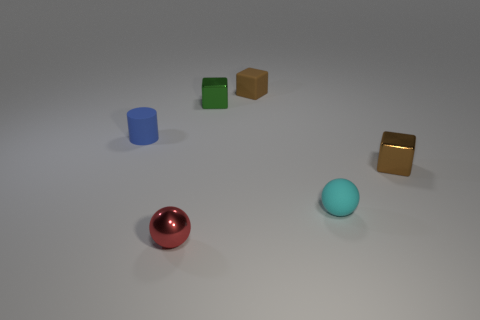What number of objects are either brown blocks behind the brown metal block or big purple metallic cubes?
Ensure brevity in your answer.  1. How many blue objects have the same material as the tiny cyan thing?
Ensure brevity in your answer.  1. The tiny thing that is the same color as the small rubber block is what shape?
Your answer should be compact. Cube. Is the number of cyan balls behind the tiny cylinder the same as the number of small yellow rubber balls?
Provide a succinct answer. Yes. How many tiny things are either cyan rubber balls or green rubber cylinders?
Provide a succinct answer. 1. There is another thing that is the same shape as the tiny red shiny thing; what is its color?
Give a very brief answer. Cyan. Do the blue cylinder and the cyan ball have the same size?
Provide a succinct answer. Yes. What number of things are either small brown metal cubes or small metallic objects behind the rubber cylinder?
Provide a succinct answer. 2. The sphere that is on the left side of the tiny cyan matte ball in front of the blue matte cylinder is what color?
Provide a short and direct response. Red. Do the tiny cube that is to the right of the small matte block and the small rubber cube have the same color?
Give a very brief answer. Yes. 